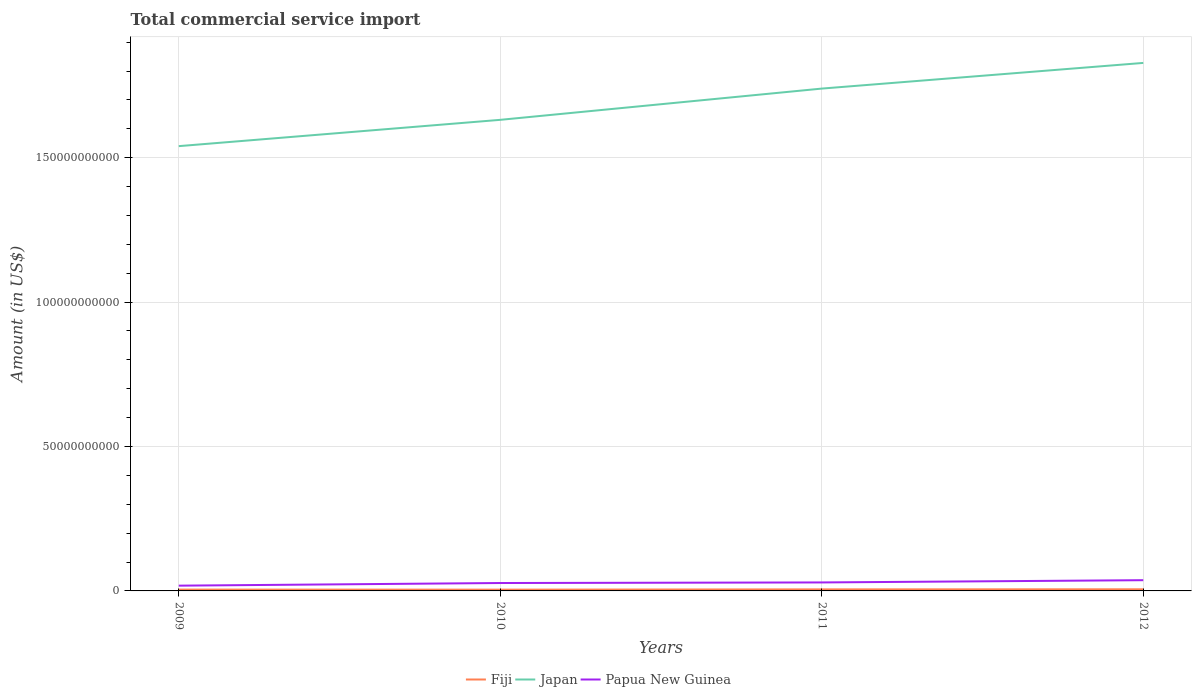Does the line corresponding to Japan intersect with the line corresponding to Fiji?
Ensure brevity in your answer.  No. Is the number of lines equal to the number of legend labels?
Your answer should be very brief. Yes. Across all years, what is the maximum total commercial service import in Fiji?
Keep it short and to the point. 4.44e+08. In which year was the total commercial service import in Fiji maximum?
Make the answer very short. 2010. What is the total total commercial service import in Papua New Guinea in the graph?
Make the answer very short. -1.11e+09. What is the difference between the highest and the second highest total commercial service import in Papua New Guinea?
Your answer should be very brief. 1.89e+09. What is the difference between the highest and the lowest total commercial service import in Papua New Guinea?
Offer a very short reply. 2. Is the total commercial service import in Fiji strictly greater than the total commercial service import in Papua New Guinea over the years?
Make the answer very short. Yes. How many lines are there?
Ensure brevity in your answer.  3. How many years are there in the graph?
Your response must be concise. 4. What is the difference between two consecutive major ticks on the Y-axis?
Provide a short and direct response. 5.00e+1. Are the values on the major ticks of Y-axis written in scientific E-notation?
Give a very brief answer. No. How many legend labels are there?
Provide a succinct answer. 3. How are the legend labels stacked?
Give a very brief answer. Horizontal. What is the title of the graph?
Your answer should be compact. Total commercial service import. Does "Iraq" appear as one of the legend labels in the graph?
Ensure brevity in your answer.  No. What is the label or title of the X-axis?
Ensure brevity in your answer.  Years. What is the Amount (in US$) in Fiji in 2009?
Make the answer very short. 4.62e+08. What is the Amount (in US$) of Japan in 2009?
Ensure brevity in your answer.  1.54e+11. What is the Amount (in US$) of Papua New Guinea in 2009?
Your response must be concise. 1.82e+09. What is the Amount (in US$) in Fiji in 2010?
Your answer should be compact. 4.44e+08. What is the Amount (in US$) in Japan in 2010?
Provide a short and direct response. 1.63e+11. What is the Amount (in US$) in Papua New Guinea in 2010?
Make the answer very short. 2.74e+09. What is the Amount (in US$) in Fiji in 2011?
Provide a succinct answer. 5.33e+08. What is the Amount (in US$) in Japan in 2011?
Provide a short and direct response. 1.74e+11. What is the Amount (in US$) of Papua New Guinea in 2011?
Make the answer very short. 2.94e+09. What is the Amount (in US$) of Fiji in 2012?
Make the answer very short. 5.62e+08. What is the Amount (in US$) in Japan in 2012?
Your response must be concise. 1.83e+11. What is the Amount (in US$) of Papua New Guinea in 2012?
Provide a succinct answer. 3.71e+09. Across all years, what is the maximum Amount (in US$) in Fiji?
Give a very brief answer. 5.62e+08. Across all years, what is the maximum Amount (in US$) of Japan?
Offer a terse response. 1.83e+11. Across all years, what is the maximum Amount (in US$) in Papua New Guinea?
Make the answer very short. 3.71e+09. Across all years, what is the minimum Amount (in US$) of Fiji?
Offer a terse response. 4.44e+08. Across all years, what is the minimum Amount (in US$) in Japan?
Provide a short and direct response. 1.54e+11. Across all years, what is the minimum Amount (in US$) of Papua New Guinea?
Ensure brevity in your answer.  1.82e+09. What is the total Amount (in US$) in Fiji in the graph?
Give a very brief answer. 2.00e+09. What is the total Amount (in US$) in Japan in the graph?
Make the answer very short. 6.74e+11. What is the total Amount (in US$) in Papua New Guinea in the graph?
Offer a very short reply. 1.12e+1. What is the difference between the Amount (in US$) of Fiji in 2009 and that in 2010?
Your answer should be compact. 1.74e+07. What is the difference between the Amount (in US$) of Japan in 2009 and that in 2010?
Offer a terse response. -9.11e+09. What is the difference between the Amount (in US$) in Papua New Guinea in 2009 and that in 2010?
Offer a terse response. -9.14e+08. What is the difference between the Amount (in US$) in Fiji in 2009 and that in 2011?
Your answer should be very brief. -7.13e+07. What is the difference between the Amount (in US$) in Japan in 2009 and that in 2011?
Provide a succinct answer. -1.99e+1. What is the difference between the Amount (in US$) in Papua New Guinea in 2009 and that in 2011?
Offer a very short reply. -1.11e+09. What is the difference between the Amount (in US$) of Fiji in 2009 and that in 2012?
Provide a short and direct response. -1.00e+08. What is the difference between the Amount (in US$) in Japan in 2009 and that in 2012?
Offer a very short reply. -2.88e+1. What is the difference between the Amount (in US$) in Papua New Guinea in 2009 and that in 2012?
Your response must be concise. -1.89e+09. What is the difference between the Amount (in US$) of Fiji in 2010 and that in 2011?
Give a very brief answer. -8.88e+07. What is the difference between the Amount (in US$) of Japan in 2010 and that in 2011?
Your answer should be very brief. -1.08e+1. What is the difference between the Amount (in US$) in Papua New Guinea in 2010 and that in 2011?
Give a very brief answer. -2.00e+08. What is the difference between the Amount (in US$) of Fiji in 2010 and that in 2012?
Your answer should be very brief. -1.17e+08. What is the difference between the Amount (in US$) of Japan in 2010 and that in 2012?
Give a very brief answer. -1.97e+1. What is the difference between the Amount (in US$) of Papua New Guinea in 2010 and that in 2012?
Give a very brief answer. -9.78e+08. What is the difference between the Amount (in US$) in Fiji in 2011 and that in 2012?
Offer a very short reply. -2.86e+07. What is the difference between the Amount (in US$) of Japan in 2011 and that in 2012?
Your answer should be compact. -8.89e+09. What is the difference between the Amount (in US$) of Papua New Guinea in 2011 and that in 2012?
Your answer should be very brief. -7.78e+08. What is the difference between the Amount (in US$) of Fiji in 2009 and the Amount (in US$) of Japan in 2010?
Your answer should be compact. -1.63e+11. What is the difference between the Amount (in US$) of Fiji in 2009 and the Amount (in US$) of Papua New Guinea in 2010?
Offer a very short reply. -2.27e+09. What is the difference between the Amount (in US$) in Japan in 2009 and the Amount (in US$) in Papua New Guinea in 2010?
Provide a succinct answer. 1.51e+11. What is the difference between the Amount (in US$) of Fiji in 2009 and the Amount (in US$) of Japan in 2011?
Provide a short and direct response. -1.73e+11. What is the difference between the Amount (in US$) of Fiji in 2009 and the Amount (in US$) of Papua New Guinea in 2011?
Provide a short and direct response. -2.47e+09. What is the difference between the Amount (in US$) of Japan in 2009 and the Amount (in US$) of Papua New Guinea in 2011?
Your answer should be compact. 1.51e+11. What is the difference between the Amount (in US$) in Fiji in 2009 and the Amount (in US$) in Japan in 2012?
Your answer should be compact. -1.82e+11. What is the difference between the Amount (in US$) in Fiji in 2009 and the Amount (in US$) in Papua New Guinea in 2012?
Ensure brevity in your answer.  -3.25e+09. What is the difference between the Amount (in US$) in Japan in 2009 and the Amount (in US$) in Papua New Guinea in 2012?
Offer a very short reply. 1.50e+11. What is the difference between the Amount (in US$) in Fiji in 2010 and the Amount (in US$) in Japan in 2011?
Give a very brief answer. -1.73e+11. What is the difference between the Amount (in US$) in Fiji in 2010 and the Amount (in US$) in Papua New Guinea in 2011?
Provide a succinct answer. -2.49e+09. What is the difference between the Amount (in US$) in Japan in 2010 and the Amount (in US$) in Papua New Guinea in 2011?
Give a very brief answer. 1.60e+11. What is the difference between the Amount (in US$) of Fiji in 2010 and the Amount (in US$) of Japan in 2012?
Your answer should be compact. -1.82e+11. What is the difference between the Amount (in US$) of Fiji in 2010 and the Amount (in US$) of Papua New Guinea in 2012?
Offer a terse response. -3.27e+09. What is the difference between the Amount (in US$) of Japan in 2010 and the Amount (in US$) of Papua New Guinea in 2012?
Give a very brief answer. 1.59e+11. What is the difference between the Amount (in US$) in Fiji in 2011 and the Amount (in US$) in Japan in 2012?
Give a very brief answer. -1.82e+11. What is the difference between the Amount (in US$) of Fiji in 2011 and the Amount (in US$) of Papua New Guinea in 2012?
Make the answer very short. -3.18e+09. What is the difference between the Amount (in US$) of Japan in 2011 and the Amount (in US$) of Papua New Guinea in 2012?
Offer a terse response. 1.70e+11. What is the average Amount (in US$) of Fiji per year?
Offer a terse response. 5.00e+08. What is the average Amount (in US$) of Japan per year?
Give a very brief answer. 1.68e+11. What is the average Amount (in US$) of Papua New Guinea per year?
Give a very brief answer. 2.80e+09. In the year 2009, what is the difference between the Amount (in US$) in Fiji and Amount (in US$) in Japan?
Make the answer very short. -1.54e+11. In the year 2009, what is the difference between the Amount (in US$) of Fiji and Amount (in US$) of Papua New Guinea?
Make the answer very short. -1.36e+09. In the year 2009, what is the difference between the Amount (in US$) in Japan and Amount (in US$) in Papua New Guinea?
Give a very brief answer. 1.52e+11. In the year 2010, what is the difference between the Amount (in US$) of Fiji and Amount (in US$) of Japan?
Ensure brevity in your answer.  -1.63e+11. In the year 2010, what is the difference between the Amount (in US$) of Fiji and Amount (in US$) of Papua New Guinea?
Keep it short and to the point. -2.29e+09. In the year 2010, what is the difference between the Amount (in US$) in Japan and Amount (in US$) in Papua New Guinea?
Provide a short and direct response. 1.60e+11. In the year 2011, what is the difference between the Amount (in US$) in Fiji and Amount (in US$) in Japan?
Make the answer very short. -1.73e+11. In the year 2011, what is the difference between the Amount (in US$) in Fiji and Amount (in US$) in Papua New Guinea?
Give a very brief answer. -2.40e+09. In the year 2011, what is the difference between the Amount (in US$) of Japan and Amount (in US$) of Papua New Guinea?
Offer a terse response. 1.71e+11. In the year 2012, what is the difference between the Amount (in US$) of Fiji and Amount (in US$) of Japan?
Ensure brevity in your answer.  -1.82e+11. In the year 2012, what is the difference between the Amount (in US$) of Fiji and Amount (in US$) of Papua New Guinea?
Your answer should be very brief. -3.15e+09. In the year 2012, what is the difference between the Amount (in US$) in Japan and Amount (in US$) in Papua New Guinea?
Your answer should be compact. 1.79e+11. What is the ratio of the Amount (in US$) in Fiji in 2009 to that in 2010?
Provide a short and direct response. 1.04. What is the ratio of the Amount (in US$) in Japan in 2009 to that in 2010?
Give a very brief answer. 0.94. What is the ratio of the Amount (in US$) in Papua New Guinea in 2009 to that in 2010?
Make the answer very short. 0.67. What is the ratio of the Amount (in US$) in Fiji in 2009 to that in 2011?
Your response must be concise. 0.87. What is the ratio of the Amount (in US$) of Japan in 2009 to that in 2011?
Make the answer very short. 0.89. What is the ratio of the Amount (in US$) of Papua New Guinea in 2009 to that in 2011?
Offer a terse response. 0.62. What is the ratio of the Amount (in US$) of Fiji in 2009 to that in 2012?
Offer a very short reply. 0.82. What is the ratio of the Amount (in US$) of Japan in 2009 to that in 2012?
Give a very brief answer. 0.84. What is the ratio of the Amount (in US$) of Papua New Guinea in 2009 to that in 2012?
Your response must be concise. 0.49. What is the ratio of the Amount (in US$) of Fiji in 2010 to that in 2011?
Provide a succinct answer. 0.83. What is the ratio of the Amount (in US$) of Japan in 2010 to that in 2011?
Provide a succinct answer. 0.94. What is the ratio of the Amount (in US$) in Papua New Guinea in 2010 to that in 2011?
Your response must be concise. 0.93. What is the ratio of the Amount (in US$) of Fiji in 2010 to that in 2012?
Your answer should be compact. 0.79. What is the ratio of the Amount (in US$) in Japan in 2010 to that in 2012?
Offer a terse response. 0.89. What is the ratio of the Amount (in US$) in Papua New Guinea in 2010 to that in 2012?
Your answer should be compact. 0.74. What is the ratio of the Amount (in US$) of Fiji in 2011 to that in 2012?
Your answer should be compact. 0.95. What is the ratio of the Amount (in US$) of Japan in 2011 to that in 2012?
Keep it short and to the point. 0.95. What is the ratio of the Amount (in US$) of Papua New Guinea in 2011 to that in 2012?
Provide a short and direct response. 0.79. What is the difference between the highest and the second highest Amount (in US$) of Fiji?
Ensure brevity in your answer.  2.86e+07. What is the difference between the highest and the second highest Amount (in US$) of Japan?
Your answer should be compact. 8.89e+09. What is the difference between the highest and the second highest Amount (in US$) of Papua New Guinea?
Give a very brief answer. 7.78e+08. What is the difference between the highest and the lowest Amount (in US$) in Fiji?
Offer a very short reply. 1.17e+08. What is the difference between the highest and the lowest Amount (in US$) in Japan?
Your answer should be very brief. 2.88e+1. What is the difference between the highest and the lowest Amount (in US$) of Papua New Guinea?
Your answer should be compact. 1.89e+09. 